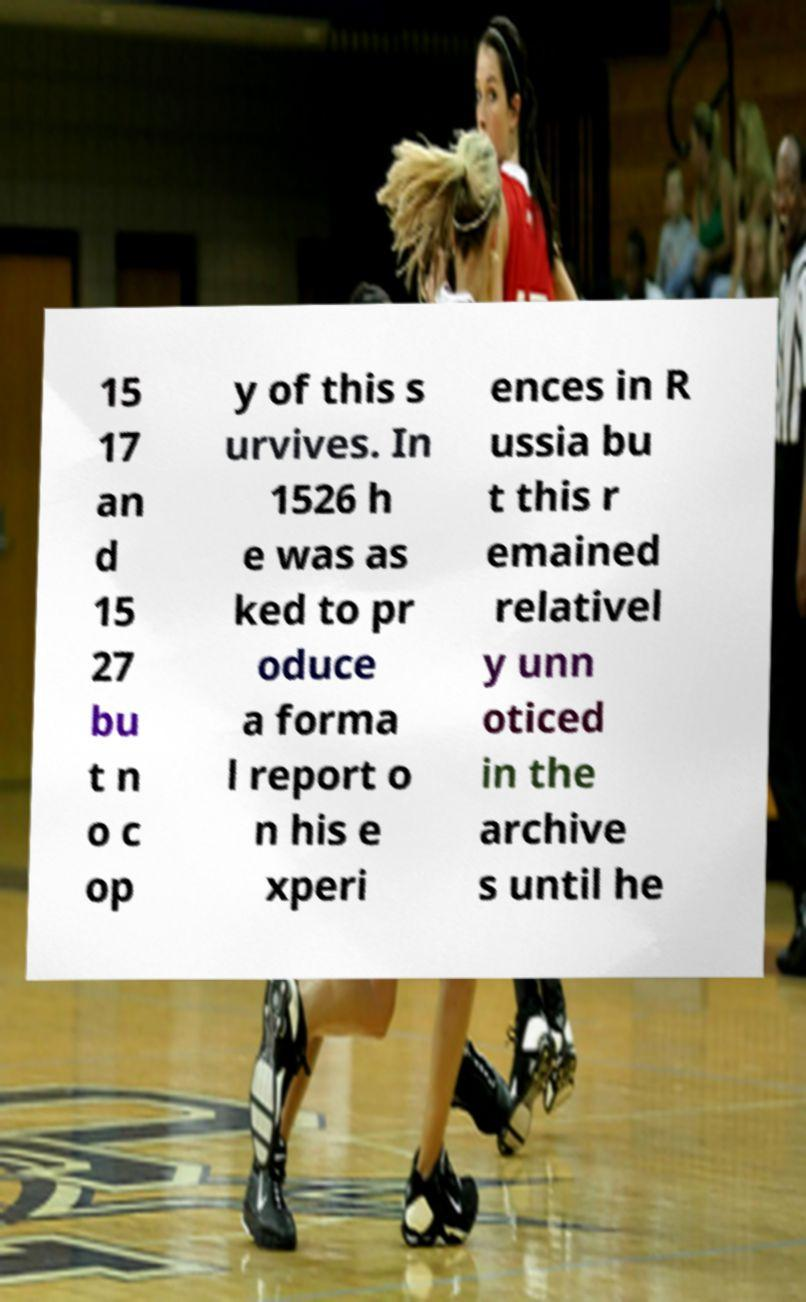For documentation purposes, I need the text within this image transcribed. Could you provide that? 15 17 an d 15 27 bu t n o c op y of this s urvives. In 1526 h e was as ked to pr oduce a forma l report o n his e xperi ences in R ussia bu t this r emained relativel y unn oticed in the archive s until he 